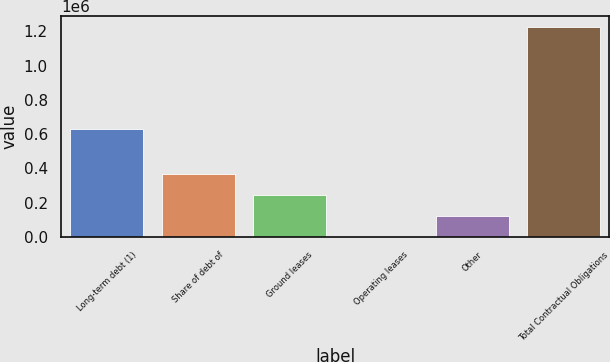Convert chart. <chart><loc_0><loc_0><loc_500><loc_500><bar_chart><fcel>Long-term debt (1)<fcel>Share of debt of<fcel>Ground leases<fcel>Operating leases<fcel>Other<fcel>Total Contractual Obligations<nl><fcel>629781<fcel>368327<fcel>245831<fcel>840<fcel>123336<fcel>1.2258e+06<nl></chart> 